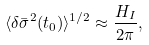Convert formula to latex. <formula><loc_0><loc_0><loc_500><loc_500>\langle \delta \bar { \sigma } ^ { 2 } ( t _ { 0 } ) \rangle ^ { 1 / 2 } \approx \frac { H _ { I } } { 2 \pi } ,</formula> 